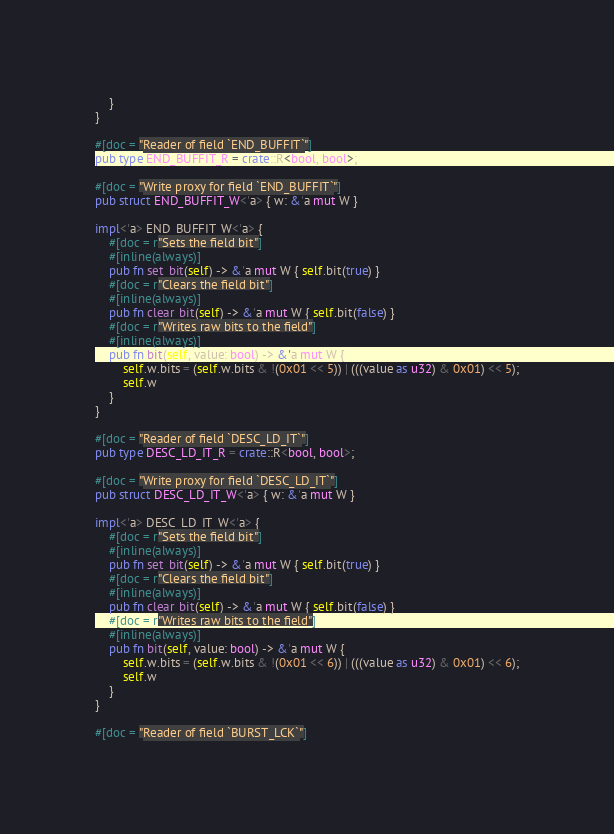Convert code to text. <code><loc_0><loc_0><loc_500><loc_500><_Rust_>    }
}

#[doc = "Reader of field `END_BUFFIT`"]
pub type END_BUFFIT_R = crate::R<bool, bool>;

#[doc = "Write proxy for field `END_BUFFIT`"]
pub struct END_BUFFIT_W<'a> { w: &'a mut W }

impl<'a> END_BUFFIT_W<'a> {
    #[doc = r"Sets the field bit"]
    #[inline(always)]
    pub fn set_bit(self) -> &'a mut W { self.bit(true) }
    #[doc = r"Clears the field bit"]
    #[inline(always)]
    pub fn clear_bit(self) -> &'a mut W { self.bit(false) }
    #[doc = r"Writes raw bits to the field"]
    #[inline(always)]
    pub fn bit(self, value: bool) -> &'a mut W {
        self.w.bits = (self.w.bits & !(0x01 << 5)) | (((value as u32) & 0x01) << 5);
        self.w
    }
}

#[doc = "Reader of field `DESC_LD_IT`"]
pub type DESC_LD_IT_R = crate::R<bool, bool>;

#[doc = "Write proxy for field `DESC_LD_IT`"]
pub struct DESC_LD_IT_W<'a> { w: &'a mut W }

impl<'a> DESC_LD_IT_W<'a> {
    #[doc = r"Sets the field bit"]
    #[inline(always)]
    pub fn set_bit(self) -> &'a mut W { self.bit(true) }
    #[doc = r"Clears the field bit"]
    #[inline(always)]
    pub fn clear_bit(self) -> &'a mut W { self.bit(false) }
    #[doc = r"Writes raw bits to the field"]
    #[inline(always)]
    pub fn bit(self, value: bool) -> &'a mut W {
        self.w.bits = (self.w.bits & !(0x01 << 6)) | (((value as u32) & 0x01) << 6);
        self.w
    }
}

#[doc = "Reader of field `BURST_LCK`"]</code> 